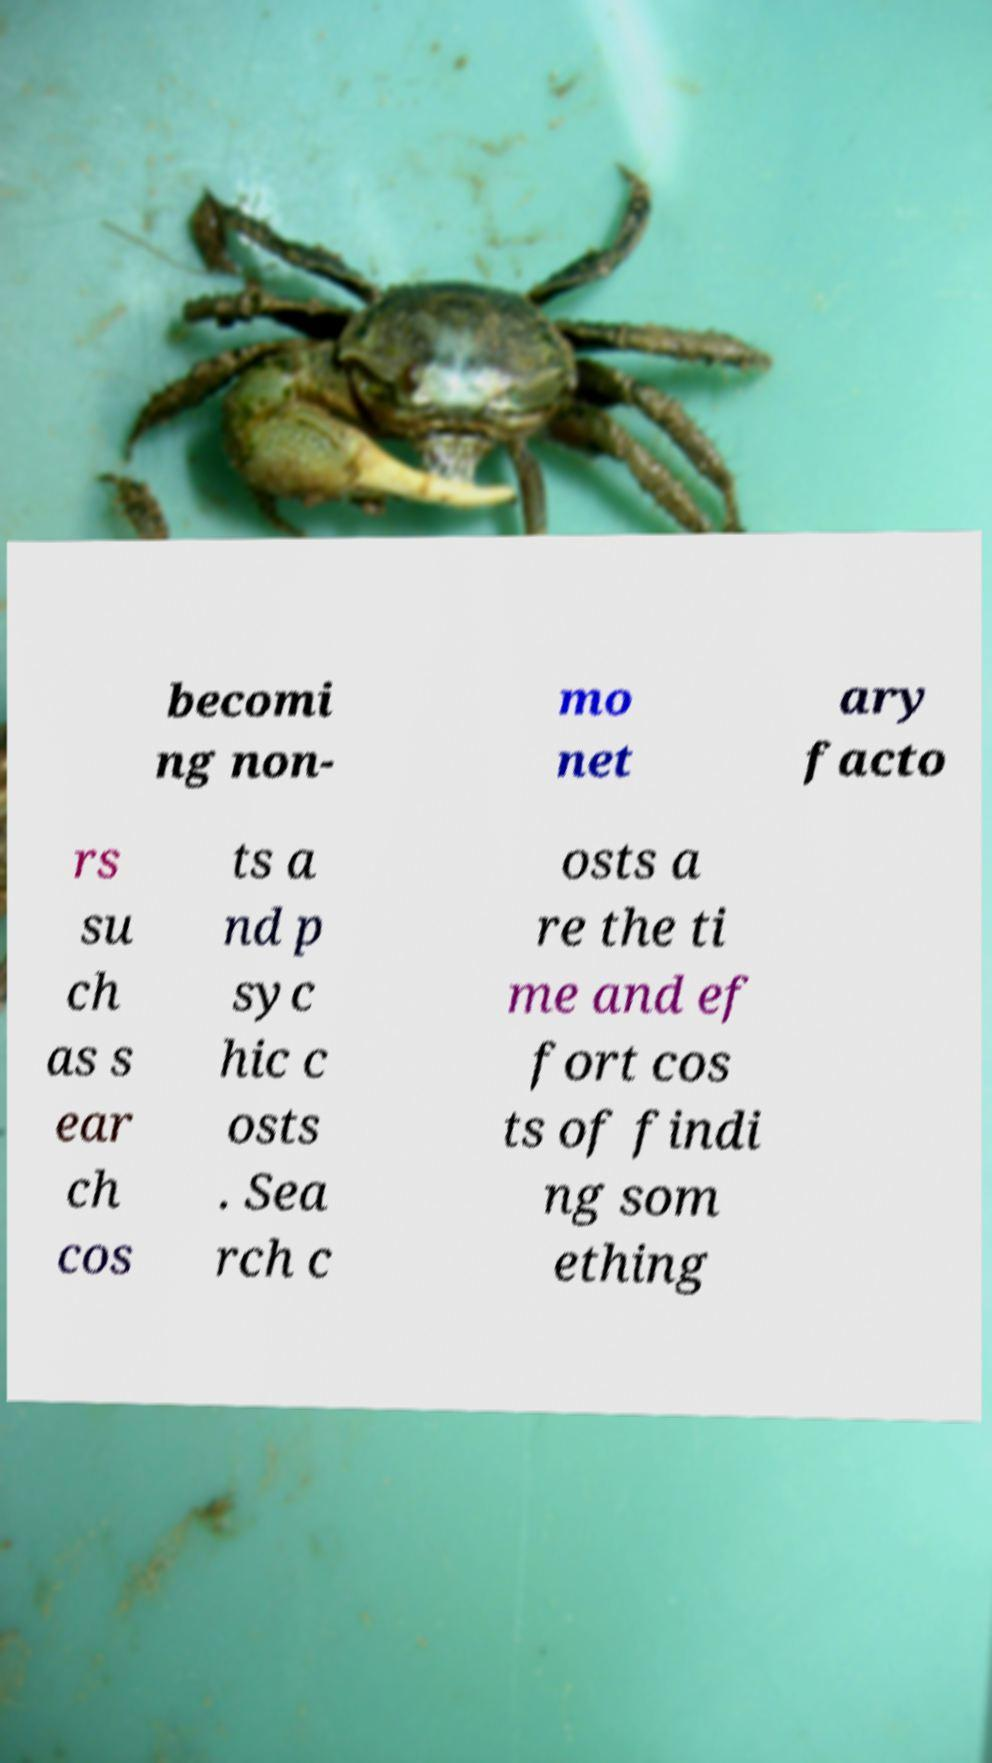Please read and relay the text visible in this image. What does it say? becomi ng non- mo net ary facto rs su ch as s ear ch cos ts a nd p syc hic c osts . Sea rch c osts a re the ti me and ef fort cos ts of findi ng som ething 